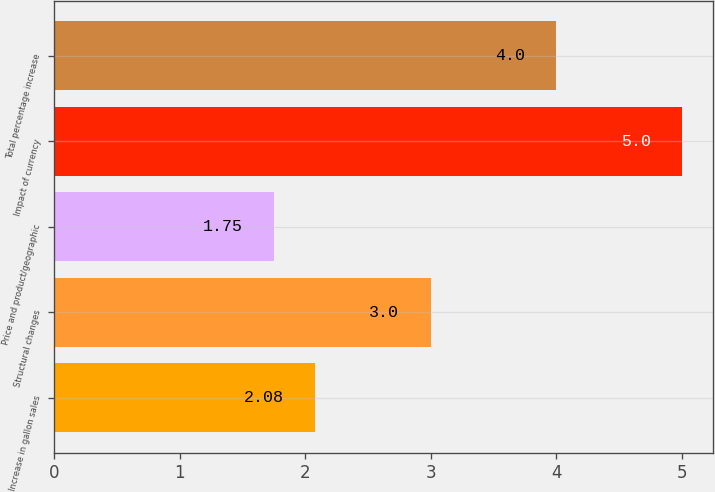Convert chart. <chart><loc_0><loc_0><loc_500><loc_500><bar_chart><fcel>Increase in gallon sales<fcel>Structural changes<fcel>Price and product/geographic<fcel>Impact of currency<fcel>Total percentage increase<nl><fcel>2.08<fcel>3<fcel>1.75<fcel>5<fcel>4<nl></chart> 